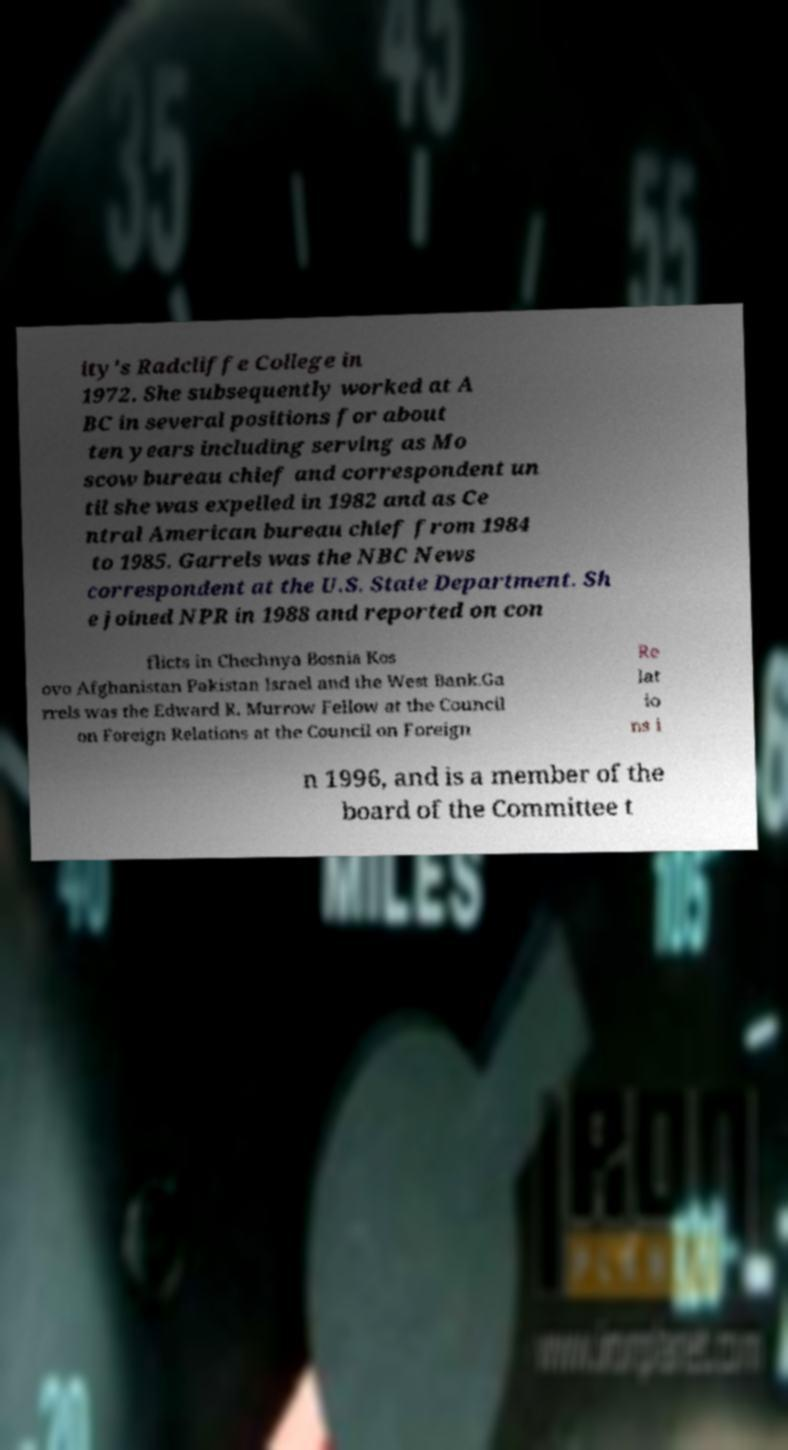Could you extract and type out the text from this image? ity's Radcliffe College in 1972. She subsequently worked at A BC in several positions for about ten years including serving as Mo scow bureau chief and correspondent un til she was expelled in 1982 and as Ce ntral American bureau chief from 1984 to 1985. Garrels was the NBC News correspondent at the U.S. State Department. Sh e joined NPR in 1988 and reported on con flicts in Chechnya Bosnia Kos ovo Afghanistan Pakistan Israel and the West Bank.Ga rrels was the Edward R. Murrow Fellow at the Council on Foreign Relations at the Council on Foreign Re lat io ns i n 1996, and is a member of the board of the Committee t 